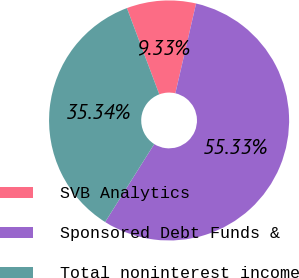Convert chart to OTSL. <chart><loc_0><loc_0><loc_500><loc_500><pie_chart><fcel>SVB Analytics<fcel>Sponsored Debt Funds &<fcel>Total noninterest income<nl><fcel>9.33%<fcel>55.33%<fcel>35.34%<nl></chart> 